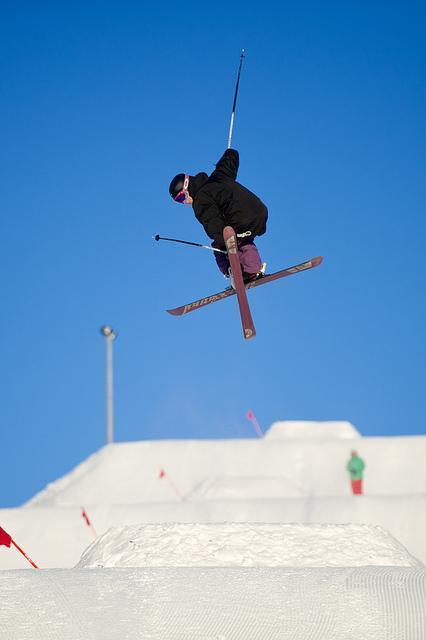How many people are jumping?
Give a very brief answer. 1. How many ski can you see?
Give a very brief answer. 1. 